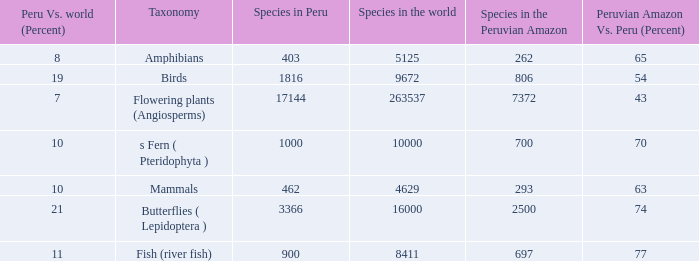What's the minimum species in the peruvian amazon with species in peru of 1000 700.0. 